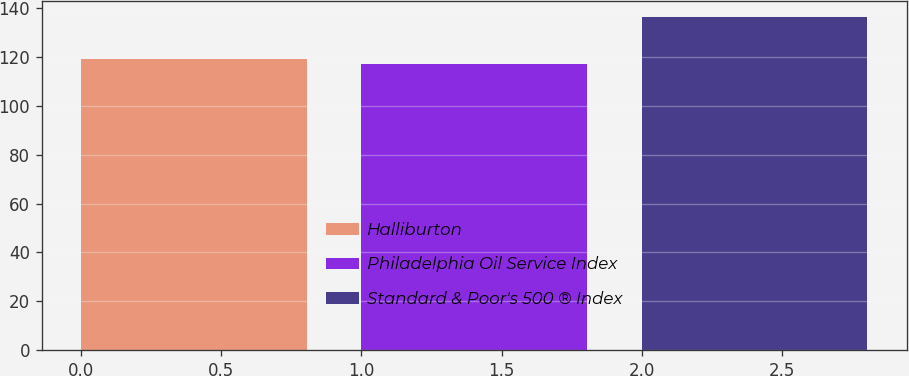Convert chart to OTSL. <chart><loc_0><loc_0><loc_500><loc_500><bar_chart><fcel>Halliburton<fcel>Philadelphia Oil Service Index<fcel>Standard & Poor's 500 ® Index<nl><fcel>119.04<fcel>117.09<fcel>136.3<nl></chart> 